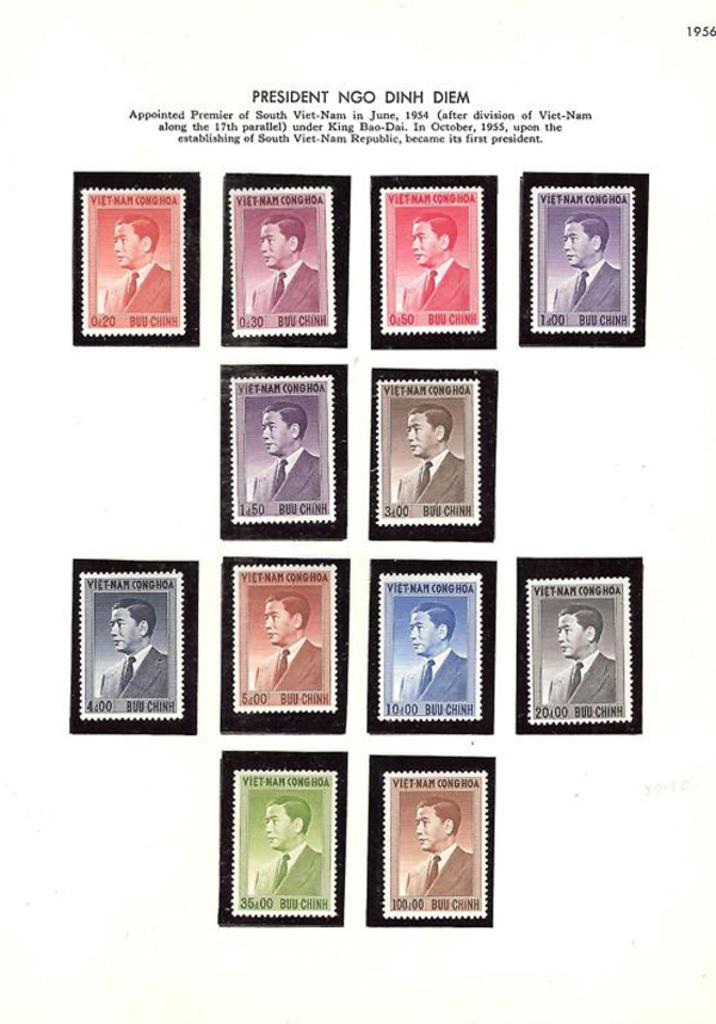What is the main subject of the image? The main subject of the image is a picture of a man. How is the man depicted in the image? The man is depicted in different colors. What type of ball is the man holding in the image? There is no ball present in the image; it only features a picture of a man depicted in different colors. What type of army is the man associated with in the image? There is no army or military context in the image; it only features a picture of a man depicted in different colors. 